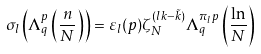<formula> <loc_0><loc_0><loc_500><loc_500>\sigma _ { l } \left ( \Lambda _ { q } ^ { p } \left ( \frac { n } { N } \right ) \right ) = \varepsilon _ { l } ( p ) \zeta _ { N } ^ { ( l k - \tilde { k } ) } \Lambda _ { q } ^ { \pi _ { l } p } \left ( \frac { \ln } { N } \right )</formula> 